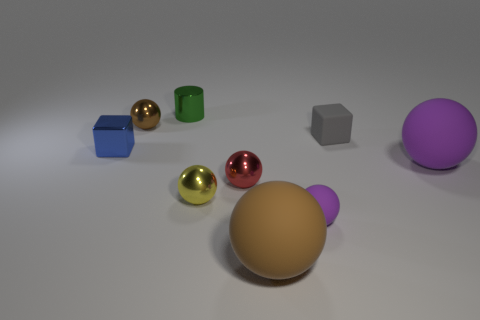Subtract all small rubber balls. How many balls are left? 5 Subtract all gray balls. Subtract all green blocks. How many balls are left? 6 Subtract all cyan spheres. How many blue cubes are left? 1 Subtract all tiny green objects. Subtract all tiny blue metallic blocks. How many objects are left? 7 Add 1 tiny yellow metallic balls. How many tiny yellow metallic balls are left? 2 Add 5 purple matte cylinders. How many purple matte cylinders exist? 5 Subtract all gray cubes. How many cubes are left? 1 Subtract 0 blue cylinders. How many objects are left? 9 Subtract all cylinders. How many objects are left? 8 Subtract 1 cylinders. How many cylinders are left? 0 